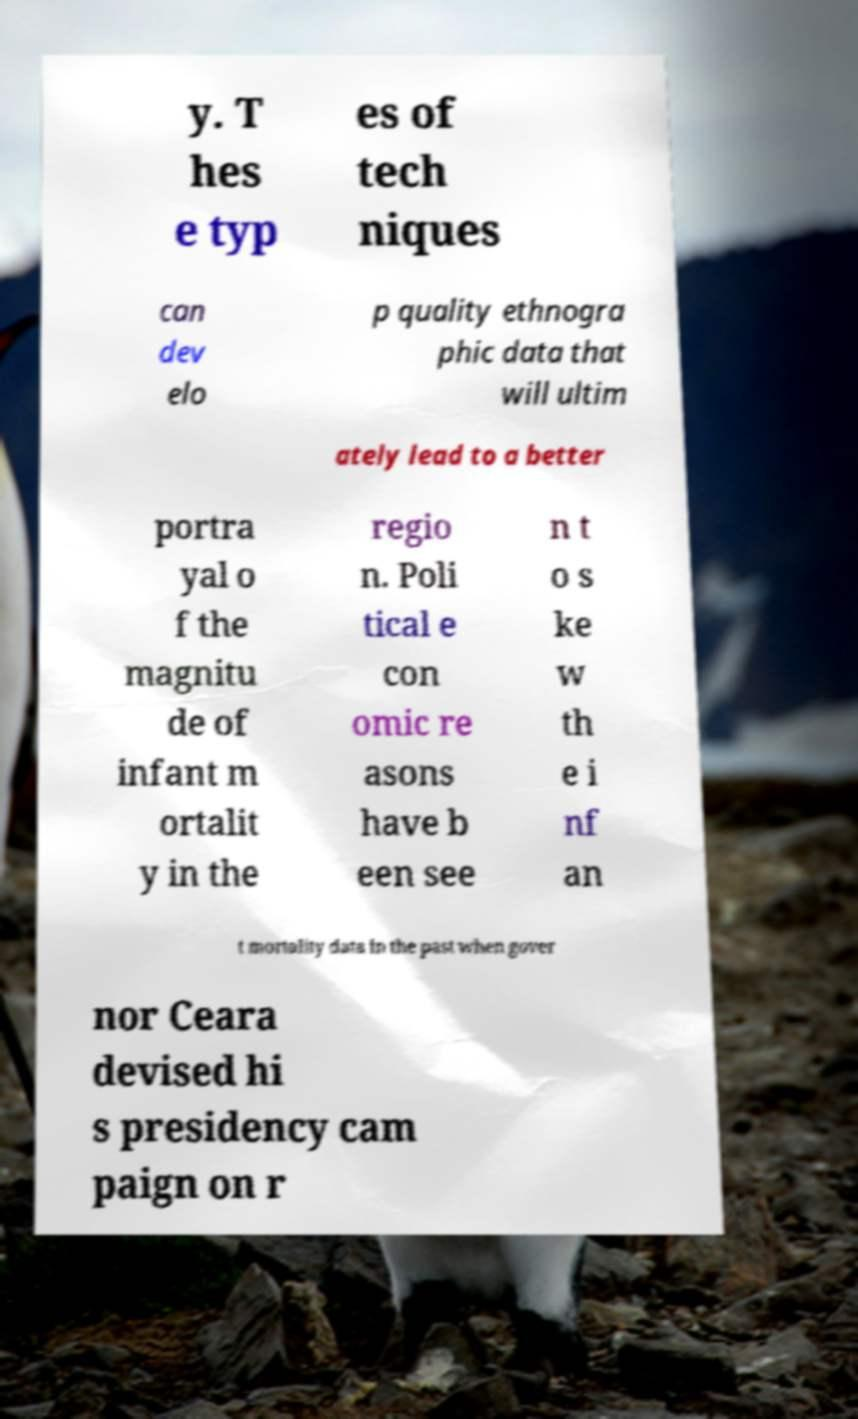Please identify and transcribe the text found in this image. y. T hes e typ es of tech niques can dev elo p quality ethnogra phic data that will ultim ately lead to a better portra yal o f the magnitu de of infant m ortalit y in the regio n. Poli tical e con omic re asons have b een see n t o s ke w th e i nf an t mortality data in the past when gover nor Ceara devised hi s presidency cam paign on r 